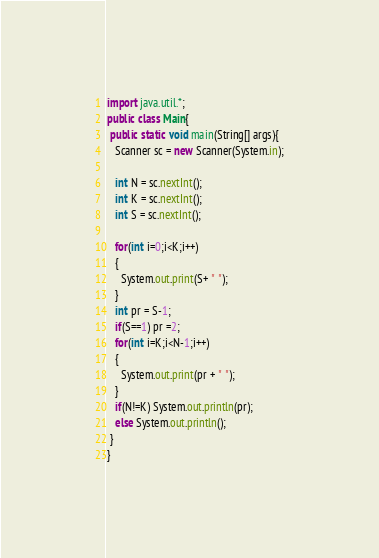Convert code to text. <code><loc_0><loc_0><loc_500><loc_500><_Java_>import java.util.*;
public class Main{
 public static void main(String[] args){
   Scanner sc = new Scanner(System.in);
 
   int N = sc.nextInt();
   int K = sc.nextInt();
   int S = sc.nextInt();
   
   for(int i=0;i<K;i++)
   {
     System.out.print(S+ " ");
   }
   int pr = S-1;
   if(S==1) pr =2; 
   for(int i=K;i<N-1;i++)
   {
     System.out.print(pr + " ");
   }
   if(N!=K) System.out.println(pr);
   else System.out.println();
 }
}</code> 